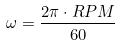Convert formula to latex. <formula><loc_0><loc_0><loc_500><loc_500>\omega = \frac { 2 \pi \cdot R P M } { 6 0 }</formula> 